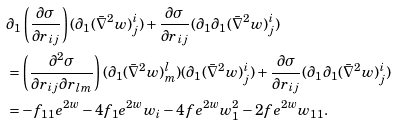<formula> <loc_0><loc_0><loc_500><loc_500>& \partial _ { 1 } \left ( \frac { \partial \sigma } { \partial r _ { i j } } \right ) ( \partial _ { 1 } ( \bar { \nabla } ^ { 2 } w ) ^ { i } _ { j } ) + \frac { \partial \sigma } { \partial r _ { i j } } ( \partial _ { 1 } \partial _ { 1 } ( \bar { \nabla } ^ { 2 } w ) ^ { i } _ { j } ) \\ & = \left ( \frac { \partial ^ { 2 } \sigma } { \partial r _ { i j } \partial r _ { l m } } \right ) ( \partial _ { 1 } ( \bar { \nabla } ^ { 2 } w ) ^ { l } _ { m } ) ( \partial _ { 1 } ( \bar { \nabla } ^ { 2 } w ) ^ { i } _ { j } ) + \frac { \partial \sigma } { \partial r _ { i j } } ( \partial _ { 1 } \partial _ { 1 } ( \bar { \nabla } ^ { 2 } w ) ^ { i } _ { j } ) \\ & = - f _ { 1 1 } e ^ { 2 w } - 4 f _ { 1 } e ^ { 2 w } w _ { i } - 4 f e ^ { 2 w } w _ { 1 } ^ { 2 } - 2 f e ^ { 2 w } w _ { 1 1 } .</formula> 